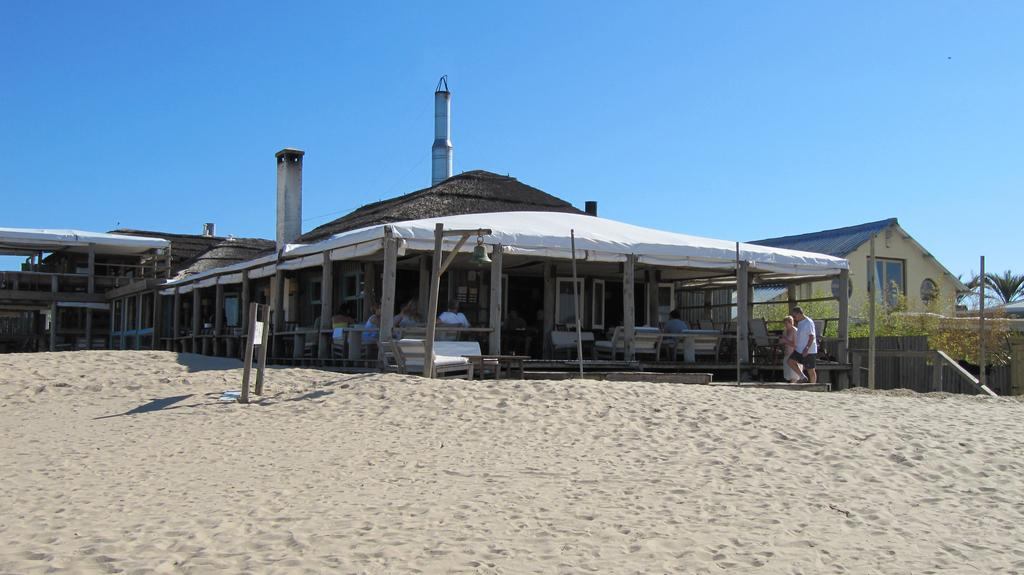What is in the foreground of the picture? There is sand in the foreground of the picture. What can be seen in the center of the picture? There are houses, trees, poles, people, benches, railing, and towers in the center of the picture. What is the condition of the sky in the picture? The sky is sunny in the picture. Can you tell me how many buckets of butter are being used by the army in the image? There is no army or buckets of butter present in the image. What type of creature is shown interacting with the sand in the foreground of the image? There is no creature shown interacting with the sand in the foreground of the image; only sand is present. 